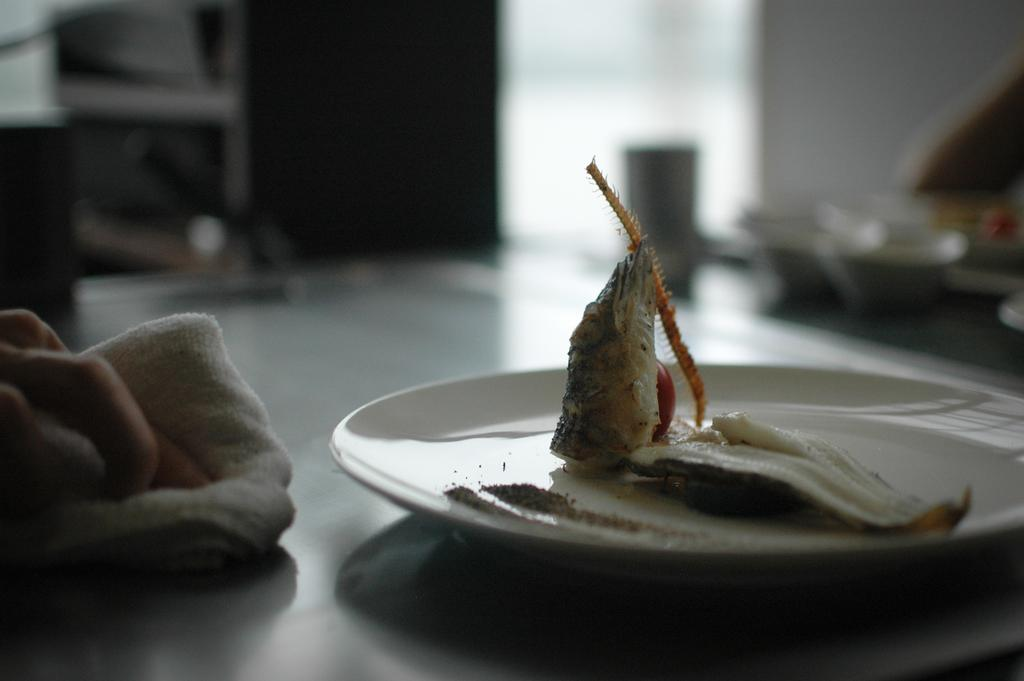What is located in the foreground of the picture? There is a table in the foreground of the picture. What is on the table? There is a plate on the table, and there is a food item on the plate. What is covering part of the table? There is a cloth on the table. Whose hand is visible in the image? A person's hand is visible in the image. How would you describe the background of the image? The background of the image is blurred. What word is written on the food item? There is no word written on the food item in the image. 